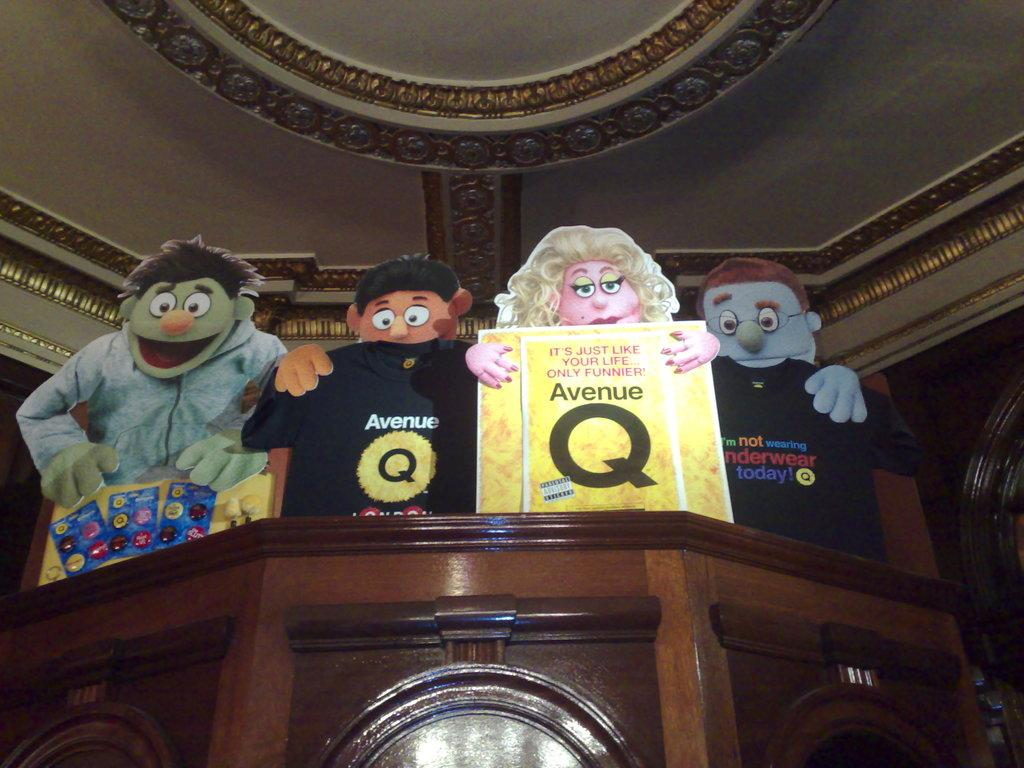What type of object is made of wood in the image? There is a wooden object in the image. What is depicted on the wooden object? The wooden object has cartoon depictions on it. What can be seen in the background of the image? There is a roof with beautiful carvings in the background of the image. How many girls are skating on the tray in the image? There is no tray or girls present in the image. The wooden object with cartoon depictions and the roof with beautiful carvings are the main subjects in the image. 